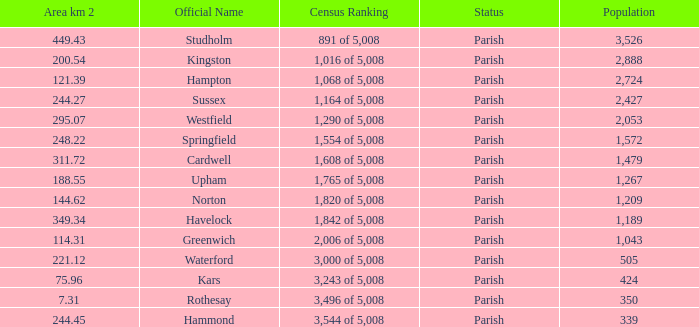What is the area in square kilometers of Studholm? 1.0. 